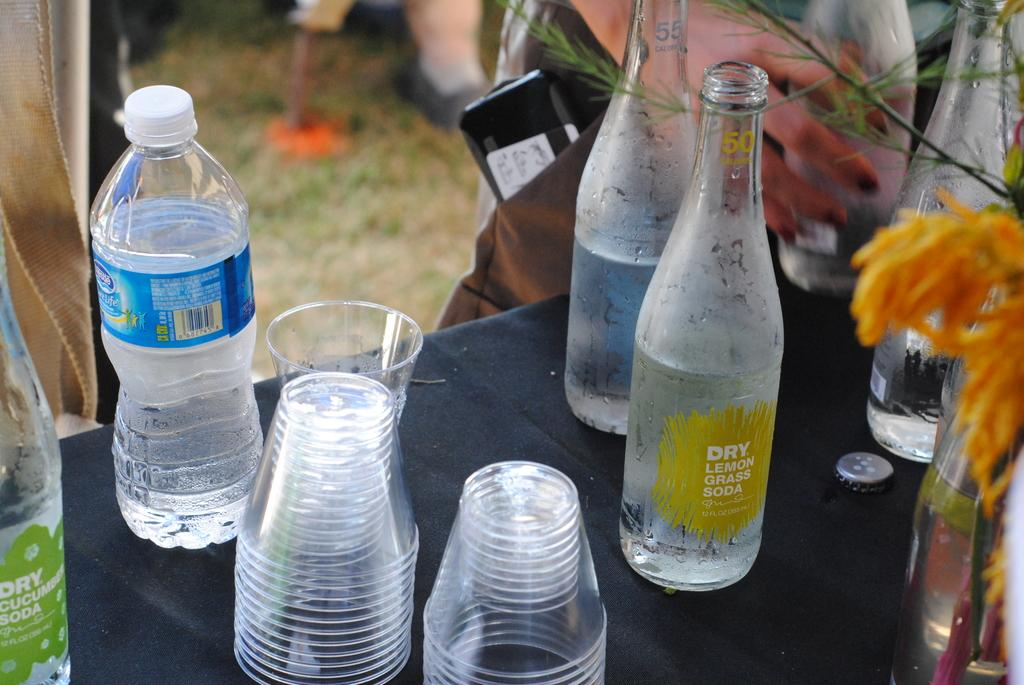What piece of furniture is present in the image? There is a table in the image. What items are placed on the table? There are bottles and glasses on the table. What type of oil can be seen dripping from the bottles in the image? There is no oil present in the image, and the bottles do not appear to be dripping anything. 